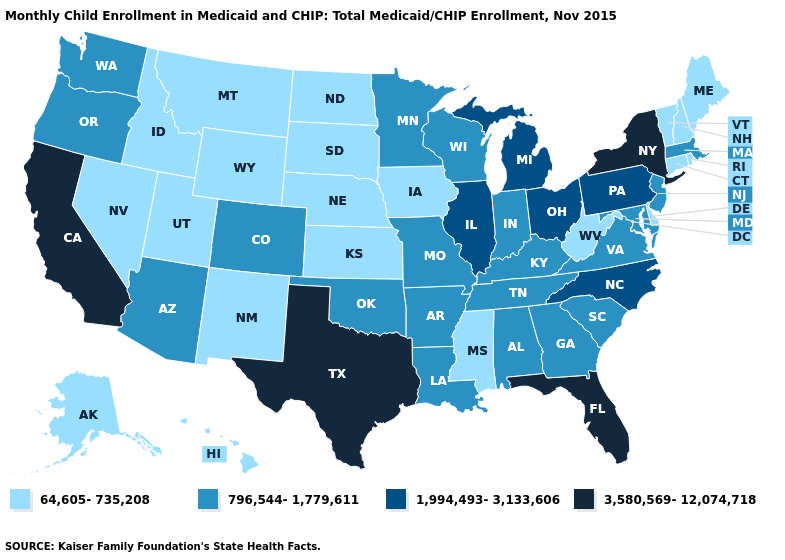Name the states that have a value in the range 796,544-1,779,611?
Quick response, please. Alabama, Arizona, Arkansas, Colorado, Georgia, Indiana, Kentucky, Louisiana, Maryland, Massachusetts, Minnesota, Missouri, New Jersey, Oklahoma, Oregon, South Carolina, Tennessee, Virginia, Washington, Wisconsin. How many symbols are there in the legend?
Short answer required. 4. Does Oregon have the same value as Colorado?
Quick response, please. Yes. What is the value of Alaska?
Keep it brief. 64,605-735,208. Name the states that have a value in the range 1,994,493-3,133,606?
Short answer required. Illinois, Michigan, North Carolina, Ohio, Pennsylvania. What is the value of Nevada?
Be succinct. 64,605-735,208. Name the states that have a value in the range 796,544-1,779,611?
Answer briefly. Alabama, Arizona, Arkansas, Colorado, Georgia, Indiana, Kentucky, Louisiana, Maryland, Massachusetts, Minnesota, Missouri, New Jersey, Oklahoma, Oregon, South Carolina, Tennessee, Virginia, Washington, Wisconsin. What is the value of Ohio?
Keep it brief. 1,994,493-3,133,606. What is the lowest value in the USA?
Give a very brief answer. 64,605-735,208. Does the map have missing data?
Keep it brief. No. Which states hav the highest value in the South?
Concise answer only. Florida, Texas. Name the states that have a value in the range 796,544-1,779,611?
Short answer required. Alabama, Arizona, Arkansas, Colorado, Georgia, Indiana, Kentucky, Louisiana, Maryland, Massachusetts, Minnesota, Missouri, New Jersey, Oklahoma, Oregon, South Carolina, Tennessee, Virginia, Washington, Wisconsin. Name the states that have a value in the range 64,605-735,208?
Answer briefly. Alaska, Connecticut, Delaware, Hawaii, Idaho, Iowa, Kansas, Maine, Mississippi, Montana, Nebraska, Nevada, New Hampshire, New Mexico, North Dakota, Rhode Island, South Dakota, Utah, Vermont, West Virginia, Wyoming. Among the states that border Colorado , does Oklahoma have the lowest value?
Quick response, please. No. 